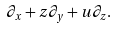<formula> <loc_0><loc_0><loc_500><loc_500>\partial _ { x } + z \partial _ { y } + u \partial _ { z } .</formula> 